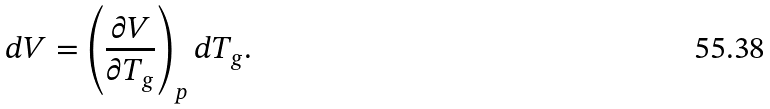Convert formula to latex. <formula><loc_0><loc_0><loc_500><loc_500>d V = \left ( \frac { \partial V } { \partial T _ { g } } \right ) _ { p } d T _ { g } .</formula> 